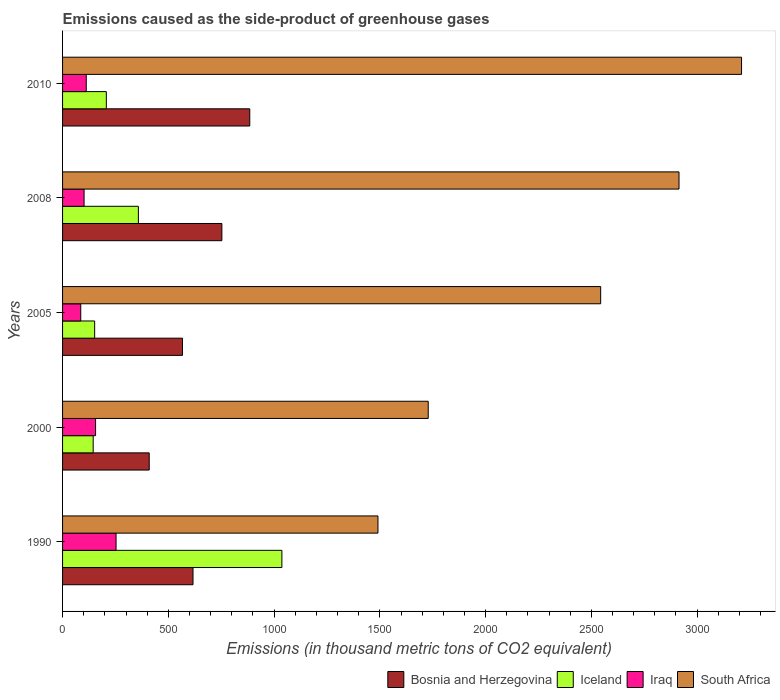Are the number of bars per tick equal to the number of legend labels?
Offer a very short reply. Yes. Are the number of bars on each tick of the Y-axis equal?
Offer a very short reply. Yes. What is the label of the 3rd group of bars from the top?
Your answer should be very brief. 2005. What is the emissions caused as the side-product of greenhouse gases in Bosnia and Herzegovina in 2010?
Provide a short and direct response. 885. Across all years, what is the maximum emissions caused as the side-product of greenhouse gases in Iceland?
Your answer should be very brief. 1036.9. Across all years, what is the minimum emissions caused as the side-product of greenhouse gases in South Africa?
Provide a short and direct response. 1491.1. In which year was the emissions caused as the side-product of greenhouse gases in South Africa maximum?
Ensure brevity in your answer.  2010. In which year was the emissions caused as the side-product of greenhouse gases in South Africa minimum?
Ensure brevity in your answer.  1990. What is the total emissions caused as the side-product of greenhouse gases in Iceland in the graph?
Ensure brevity in your answer.  1898.9. What is the difference between the emissions caused as the side-product of greenhouse gases in Bosnia and Herzegovina in 1990 and that in 2008?
Your answer should be very brief. -136.5. What is the difference between the emissions caused as the side-product of greenhouse gases in Iceland in 2000 and the emissions caused as the side-product of greenhouse gases in Bosnia and Herzegovina in 2008?
Your answer should be very brief. -608.4. What is the average emissions caused as the side-product of greenhouse gases in Iceland per year?
Your response must be concise. 379.78. In the year 2000, what is the difference between the emissions caused as the side-product of greenhouse gases in Iraq and emissions caused as the side-product of greenhouse gases in South Africa?
Offer a very short reply. -1572.7. What is the ratio of the emissions caused as the side-product of greenhouse gases in South Africa in 2008 to that in 2010?
Provide a short and direct response. 0.91. Is the emissions caused as the side-product of greenhouse gases in Iceland in 1990 less than that in 2010?
Give a very brief answer. No. Is the difference between the emissions caused as the side-product of greenhouse gases in Iraq in 2000 and 2010 greater than the difference between the emissions caused as the side-product of greenhouse gases in South Africa in 2000 and 2010?
Give a very brief answer. Yes. What is the difference between the highest and the second highest emissions caused as the side-product of greenhouse gases in Bosnia and Herzegovina?
Your response must be concise. 131.8. What is the difference between the highest and the lowest emissions caused as the side-product of greenhouse gases in South Africa?
Ensure brevity in your answer.  1718.9. In how many years, is the emissions caused as the side-product of greenhouse gases in Iraq greater than the average emissions caused as the side-product of greenhouse gases in Iraq taken over all years?
Provide a succinct answer. 2. Is it the case that in every year, the sum of the emissions caused as the side-product of greenhouse gases in Bosnia and Herzegovina and emissions caused as the side-product of greenhouse gases in Iceland is greater than the sum of emissions caused as the side-product of greenhouse gases in South Africa and emissions caused as the side-product of greenhouse gases in Iraq?
Offer a terse response. No. What does the 1st bar from the top in 2000 represents?
Offer a terse response. South Africa. Is it the case that in every year, the sum of the emissions caused as the side-product of greenhouse gases in Bosnia and Herzegovina and emissions caused as the side-product of greenhouse gases in Iceland is greater than the emissions caused as the side-product of greenhouse gases in Iraq?
Keep it short and to the point. Yes. How many bars are there?
Make the answer very short. 20. Are all the bars in the graph horizontal?
Make the answer very short. Yes. Are the values on the major ticks of X-axis written in scientific E-notation?
Offer a terse response. No. How many legend labels are there?
Provide a short and direct response. 4. What is the title of the graph?
Offer a very short reply. Emissions caused as the side-product of greenhouse gases. What is the label or title of the X-axis?
Give a very brief answer. Emissions (in thousand metric tons of CO2 equivalent). What is the Emissions (in thousand metric tons of CO2 equivalent) in Bosnia and Herzegovina in 1990?
Provide a short and direct response. 616.7. What is the Emissions (in thousand metric tons of CO2 equivalent) in Iceland in 1990?
Ensure brevity in your answer.  1036.9. What is the Emissions (in thousand metric tons of CO2 equivalent) of Iraq in 1990?
Provide a succinct answer. 252.9. What is the Emissions (in thousand metric tons of CO2 equivalent) of South Africa in 1990?
Your answer should be very brief. 1491.1. What is the Emissions (in thousand metric tons of CO2 equivalent) in Bosnia and Herzegovina in 2000?
Provide a succinct answer. 409.7. What is the Emissions (in thousand metric tons of CO2 equivalent) of Iceland in 2000?
Offer a very short reply. 144.8. What is the Emissions (in thousand metric tons of CO2 equivalent) in Iraq in 2000?
Offer a terse response. 156.1. What is the Emissions (in thousand metric tons of CO2 equivalent) of South Africa in 2000?
Offer a terse response. 1728.8. What is the Emissions (in thousand metric tons of CO2 equivalent) of Bosnia and Herzegovina in 2005?
Keep it short and to the point. 566.9. What is the Emissions (in thousand metric tons of CO2 equivalent) of Iceland in 2005?
Ensure brevity in your answer.  151.7. What is the Emissions (in thousand metric tons of CO2 equivalent) in South Africa in 2005?
Provide a succinct answer. 2544. What is the Emissions (in thousand metric tons of CO2 equivalent) of Bosnia and Herzegovina in 2008?
Provide a succinct answer. 753.2. What is the Emissions (in thousand metric tons of CO2 equivalent) in Iceland in 2008?
Your answer should be very brief. 358.5. What is the Emissions (in thousand metric tons of CO2 equivalent) of Iraq in 2008?
Keep it short and to the point. 101.7. What is the Emissions (in thousand metric tons of CO2 equivalent) in South Africa in 2008?
Your response must be concise. 2914.4. What is the Emissions (in thousand metric tons of CO2 equivalent) in Bosnia and Herzegovina in 2010?
Give a very brief answer. 885. What is the Emissions (in thousand metric tons of CO2 equivalent) in Iceland in 2010?
Your answer should be very brief. 207. What is the Emissions (in thousand metric tons of CO2 equivalent) in Iraq in 2010?
Give a very brief answer. 112. What is the Emissions (in thousand metric tons of CO2 equivalent) in South Africa in 2010?
Provide a succinct answer. 3210. Across all years, what is the maximum Emissions (in thousand metric tons of CO2 equivalent) of Bosnia and Herzegovina?
Your answer should be very brief. 885. Across all years, what is the maximum Emissions (in thousand metric tons of CO2 equivalent) of Iceland?
Offer a very short reply. 1036.9. Across all years, what is the maximum Emissions (in thousand metric tons of CO2 equivalent) of Iraq?
Keep it short and to the point. 252.9. Across all years, what is the maximum Emissions (in thousand metric tons of CO2 equivalent) of South Africa?
Provide a short and direct response. 3210. Across all years, what is the minimum Emissions (in thousand metric tons of CO2 equivalent) of Bosnia and Herzegovina?
Keep it short and to the point. 409.7. Across all years, what is the minimum Emissions (in thousand metric tons of CO2 equivalent) in Iceland?
Make the answer very short. 144.8. Across all years, what is the minimum Emissions (in thousand metric tons of CO2 equivalent) in South Africa?
Offer a terse response. 1491.1. What is the total Emissions (in thousand metric tons of CO2 equivalent) of Bosnia and Herzegovina in the graph?
Provide a short and direct response. 3231.5. What is the total Emissions (in thousand metric tons of CO2 equivalent) of Iceland in the graph?
Offer a very short reply. 1898.9. What is the total Emissions (in thousand metric tons of CO2 equivalent) of Iraq in the graph?
Provide a succinct answer. 708.7. What is the total Emissions (in thousand metric tons of CO2 equivalent) in South Africa in the graph?
Offer a very short reply. 1.19e+04. What is the difference between the Emissions (in thousand metric tons of CO2 equivalent) of Bosnia and Herzegovina in 1990 and that in 2000?
Your response must be concise. 207. What is the difference between the Emissions (in thousand metric tons of CO2 equivalent) of Iceland in 1990 and that in 2000?
Keep it short and to the point. 892.1. What is the difference between the Emissions (in thousand metric tons of CO2 equivalent) in Iraq in 1990 and that in 2000?
Provide a succinct answer. 96.8. What is the difference between the Emissions (in thousand metric tons of CO2 equivalent) in South Africa in 1990 and that in 2000?
Offer a very short reply. -237.7. What is the difference between the Emissions (in thousand metric tons of CO2 equivalent) in Bosnia and Herzegovina in 1990 and that in 2005?
Make the answer very short. 49.8. What is the difference between the Emissions (in thousand metric tons of CO2 equivalent) of Iceland in 1990 and that in 2005?
Provide a succinct answer. 885.2. What is the difference between the Emissions (in thousand metric tons of CO2 equivalent) of Iraq in 1990 and that in 2005?
Your response must be concise. 166.9. What is the difference between the Emissions (in thousand metric tons of CO2 equivalent) in South Africa in 1990 and that in 2005?
Your answer should be compact. -1052.9. What is the difference between the Emissions (in thousand metric tons of CO2 equivalent) of Bosnia and Herzegovina in 1990 and that in 2008?
Make the answer very short. -136.5. What is the difference between the Emissions (in thousand metric tons of CO2 equivalent) in Iceland in 1990 and that in 2008?
Ensure brevity in your answer.  678.4. What is the difference between the Emissions (in thousand metric tons of CO2 equivalent) in Iraq in 1990 and that in 2008?
Keep it short and to the point. 151.2. What is the difference between the Emissions (in thousand metric tons of CO2 equivalent) in South Africa in 1990 and that in 2008?
Give a very brief answer. -1423.3. What is the difference between the Emissions (in thousand metric tons of CO2 equivalent) in Bosnia and Herzegovina in 1990 and that in 2010?
Ensure brevity in your answer.  -268.3. What is the difference between the Emissions (in thousand metric tons of CO2 equivalent) of Iceland in 1990 and that in 2010?
Your response must be concise. 829.9. What is the difference between the Emissions (in thousand metric tons of CO2 equivalent) in Iraq in 1990 and that in 2010?
Your answer should be very brief. 140.9. What is the difference between the Emissions (in thousand metric tons of CO2 equivalent) of South Africa in 1990 and that in 2010?
Offer a terse response. -1718.9. What is the difference between the Emissions (in thousand metric tons of CO2 equivalent) in Bosnia and Herzegovina in 2000 and that in 2005?
Your answer should be compact. -157.2. What is the difference between the Emissions (in thousand metric tons of CO2 equivalent) in Iceland in 2000 and that in 2005?
Your response must be concise. -6.9. What is the difference between the Emissions (in thousand metric tons of CO2 equivalent) of Iraq in 2000 and that in 2005?
Your answer should be compact. 70.1. What is the difference between the Emissions (in thousand metric tons of CO2 equivalent) of South Africa in 2000 and that in 2005?
Give a very brief answer. -815.2. What is the difference between the Emissions (in thousand metric tons of CO2 equivalent) in Bosnia and Herzegovina in 2000 and that in 2008?
Ensure brevity in your answer.  -343.5. What is the difference between the Emissions (in thousand metric tons of CO2 equivalent) of Iceland in 2000 and that in 2008?
Make the answer very short. -213.7. What is the difference between the Emissions (in thousand metric tons of CO2 equivalent) in Iraq in 2000 and that in 2008?
Your response must be concise. 54.4. What is the difference between the Emissions (in thousand metric tons of CO2 equivalent) of South Africa in 2000 and that in 2008?
Your answer should be very brief. -1185.6. What is the difference between the Emissions (in thousand metric tons of CO2 equivalent) of Bosnia and Herzegovina in 2000 and that in 2010?
Keep it short and to the point. -475.3. What is the difference between the Emissions (in thousand metric tons of CO2 equivalent) in Iceland in 2000 and that in 2010?
Make the answer very short. -62.2. What is the difference between the Emissions (in thousand metric tons of CO2 equivalent) in Iraq in 2000 and that in 2010?
Your answer should be compact. 44.1. What is the difference between the Emissions (in thousand metric tons of CO2 equivalent) of South Africa in 2000 and that in 2010?
Offer a very short reply. -1481.2. What is the difference between the Emissions (in thousand metric tons of CO2 equivalent) of Bosnia and Herzegovina in 2005 and that in 2008?
Offer a very short reply. -186.3. What is the difference between the Emissions (in thousand metric tons of CO2 equivalent) in Iceland in 2005 and that in 2008?
Provide a short and direct response. -206.8. What is the difference between the Emissions (in thousand metric tons of CO2 equivalent) in Iraq in 2005 and that in 2008?
Make the answer very short. -15.7. What is the difference between the Emissions (in thousand metric tons of CO2 equivalent) in South Africa in 2005 and that in 2008?
Your answer should be compact. -370.4. What is the difference between the Emissions (in thousand metric tons of CO2 equivalent) of Bosnia and Herzegovina in 2005 and that in 2010?
Ensure brevity in your answer.  -318.1. What is the difference between the Emissions (in thousand metric tons of CO2 equivalent) of Iceland in 2005 and that in 2010?
Your answer should be very brief. -55.3. What is the difference between the Emissions (in thousand metric tons of CO2 equivalent) of South Africa in 2005 and that in 2010?
Provide a succinct answer. -666. What is the difference between the Emissions (in thousand metric tons of CO2 equivalent) of Bosnia and Herzegovina in 2008 and that in 2010?
Give a very brief answer. -131.8. What is the difference between the Emissions (in thousand metric tons of CO2 equivalent) in Iceland in 2008 and that in 2010?
Ensure brevity in your answer.  151.5. What is the difference between the Emissions (in thousand metric tons of CO2 equivalent) of Iraq in 2008 and that in 2010?
Offer a terse response. -10.3. What is the difference between the Emissions (in thousand metric tons of CO2 equivalent) of South Africa in 2008 and that in 2010?
Offer a very short reply. -295.6. What is the difference between the Emissions (in thousand metric tons of CO2 equivalent) of Bosnia and Herzegovina in 1990 and the Emissions (in thousand metric tons of CO2 equivalent) of Iceland in 2000?
Provide a succinct answer. 471.9. What is the difference between the Emissions (in thousand metric tons of CO2 equivalent) of Bosnia and Herzegovina in 1990 and the Emissions (in thousand metric tons of CO2 equivalent) of Iraq in 2000?
Ensure brevity in your answer.  460.6. What is the difference between the Emissions (in thousand metric tons of CO2 equivalent) in Bosnia and Herzegovina in 1990 and the Emissions (in thousand metric tons of CO2 equivalent) in South Africa in 2000?
Your answer should be compact. -1112.1. What is the difference between the Emissions (in thousand metric tons of CO2 equivalent) in Iceland in 1990 and the Emissions (in thousand metric tons of CO2 equivalent) in Iraq in 2000?
Make the answer very short. 880.8. What is the difference between the Emissions (in thousand metric tons of CO2 equivalent) of Iceland in 1990 and the Emissions (in thousand metric tons of CO2 equivalent) of South Africa in 2000?
Your answer should be very brief. -691.9. What is the difference between the Emissions (in thousand metric tons of CO2 equivalent) of Iraq in 1990 and the Emissions (in thousand metric tons of CO2 equivalent) of South Africa in 2000?
Offer a terse response. -1475.9. What is the difference between the Emissions (in thousand metric tons of CO2 equivalent) of Bosnia and Herzegovina in 1990 and the Emissions (in thousand metric tons of CO2 equivalent) of Iceland in 2005?
Your answer should be very brief. 465. What is the difference between the Emissions (in thousand metric tons of CO2 equivalent) of Bosnia and Herzegovina in 1990 and the Emissions (in thousand metric tons of CO2 equivalent) of Iraq in 2005?
Offer a terse response. 530.7. What is the difference between the Emissions (in thousand metric tons of CO2 equivalent) in Bosnia and Herzegovina in 1990 and the Emissions (in thousand metric tons of CO2 equivalent) in South Africa in 2005?
Ensure brevity in your answer.  -1927.3. What is the difference between the Emissions (in thousand metric tons of CO2 equivalent) in Iceland in 1990 and the Emissions (in thousand metric tons of CO2 equivalent) in Iraq in 2005?
Provide a succinct answer. 950.9. What is the difference between the Emissions (in thousand metric tons of CO2 equivalent) in Iceland in 1990 and the Emissions (in thousand metric tons of CO2 equivalent) in South Africa in 2005?
Offer a very short reply. -1507.1. What is the difference between the Emissions (in thousand metric tons of CO2 equivalent) of Iraq in 1990 and the Emissions (in thousand metric tons of CO2 equivalent) of South Africa in 2005?
Keep it short and to the point. -2291.1. What is the difference between the Emissions (in thousand metric tons of CO2 equivalent) of Bosnia and Herzegovina in 1990 and the Emissions (in thousand metric tons of CO2 equivalent) of Iceland in 2008?
Your answer should be very brief. 258.2. What is the difference between the Emissions (in thousand metric tons of CO2 equivalent) of Bosnia and Herzegovina in 1990 and the Emissions (in thousand metric tons of CO2 equivalent) of Iraq in 2008?
Give a very brief answer. 515. What is the difference between the Emissions (in thousand metric tons of CO2 equivalent) in Bosnia and Herzegovina in 1990 and the Emissions (in thousand metric tons of CO2 equivalent) in South Africa in 2008?
Ensure brevity in your answer.  -2297.7. What is the difference between the Emissions (in thousand metric tons of CO2 equivalent) of Iceland in 1990 and the Emissions (in thousand metric tons of CO2 equivalent) of Iraq in 2008?
Ensure brevity in your answer.  935.2. What is the difference between the Emissions (in thousand metric tons of CO2 equivalent) in Iceland in 1990 and the Emissions (in thousand metric tons of CO2 equivalent) in South Africa in 2008?
Your answer should be compact. -1877.5. What is the difference between the Emissions (in thousand metric tons of CO2 equivalent) in Iraq in 1990 and the Emissions (in thousand metric tons of CO2 equivalent) in South Africa in 2008?
Your answer should be very brief. -2661.5. What is the difference between the Emissions (in thousand metric tons of CO2 equivalent) of Bosnia and Herzegovina in 1990 and the Emissions (in thousand metric tons of CO2 equivalent) of Iceland in 2010?
Give a very brief answer. 409.7. What is the difference between the Emissions (in thousand metric tons of CO2 equivalent) in Bosnia and Herzegovina in 1990 and the Emissions (in thousand metric tons of CO2 equivalent) in Iraq in 2010?
Offer a very short reply. 504.7. What is the difference between the Emissions (in thousand metric tons of CO2 equivalent) in Bosnia and Herzegovina in 1990 and the Emissions (in thousand metric tons of CO2 equivalent) in South Africa in 2010?
Offer a very short reply. -2593.3. What is the difference between the Emissions (in thousand metric tons of CO2 equivalent) in Iceland in 1990 and the Emissions (in thousand metric tons of CO2 equivalent) in Iraq in 2010?
Your answer should be very brief. 924.9. What is the difference between the Emissions (in thousand metric tons of CO2 equivalent) of Iceland in 1990 and the Emissions (in thousand metric tons of CO2 equivalent) of South Africa in 2010?
Your answer should be very brief. -2173.1. What is the difference between the Emissions (in thousand metric tons of CO2 equivalent) in Iraq in 1990 and the Emissions (in thousand metric tons of CO2 equivalent) in South Africa in 2010?
Provide a succinct answer. -2957.1. What is the difference between the Emissions (in thousand metric tons of CO2 equivalent) of Bosnia and Herzegovina in 2000 and the Emissions (in thousand metric tons of CO2 equivalent) of Iceland in 2005?
Your answer should be compact. 258. What is the difference between the Emissions (in thousand metric tons of CO2 equivalent) in Bosnia and Herzegovina in 2000 and the Emissions (in thousand metric tons of CO2 equivalent) in Iraq in 2005?
Keep it short and to the point. 323.7. What is the difference between the Emissions (in thousand metric tons of CO2 equivalent) of Bosnia and Herzegovina in 2000 and the Emissions (in thousand metric tons of CO2 equivalent) of South Africa in 2005?
Make the answer very short. -2134.3. What is the difference between the Emissions (in thousand metric tons of CO2 equivalent) in Iceland in 2000 and the Emissions (in thousand metric tons of CO2 equivalent) in Iraq in 2005?
Provide a succinct answer. 58.8. What is the difference between the Emissions (in thousand metric tons of CO2 equivalent) in Iceland in 2000 and the Emissions (in thousand metric tons of CO2 equivalent) in South Africa in 2005?
Your answer should be very brief. -2399.2. What is the difference between the Emissions (in thousand metric tons of CO2 equivalent) in Iraq in 2000 and the Emissions (in thousand metric tons of CO2 equivalent) in South Africa in 2005?
Give a very brief answer. -2387.9. What is the difference between the Emissions (in thousand metric tons of CO2 equivalent) of Bosnia and Herzegovina in 2000 and the Emissions (in thousand metric tons of CO2 equivalent) of Iceland in 2008?
Provide a short and direct response. 51.2. What is the difference between the Emissions (in thousand metric tons of CO2 equivalent) in Bosnia and Herzegovina in 2000 and the Emissions (in thousand metric tons of CO2 equivalent) in Iraq in 2008?
Offer a terse response. 308. What is the difference between the Emissions (in thousand metric tons of CO2 equivalent) in Bosnia and Herzegovina in 2000 and the Emissions (in thousand metric tons of CO2 equivalent) in South Africa in 2008?
Offer a terse response. -2504.7. What is the difference between the Emissions (in thousand metric tons of CO2 equivalent) of Iceland in 2000 and the Emissions (in thousand metric tons of CO2 equivalent) of Iraq in 2008?
Offer a terse response. 43.1. What is the difference between the Emissions (in thousand metric tons of CO2 equivalent) of Iceland in 2000 and the Emissions (in thousand metric tons of CO2 equivalent) of South Africa in 2008?
Your answer should be very brief. -2769.6. What is the difference between the Emissions (in thousand metric tons of CO2 equivalent) in Iraq in 2000 and the Emissions (in thousand metric tons of CO2 equivalent) in South Africa in 2008?
Offer a terse response. -2758.3. What is the difference between the Emissions (in thousand metric tons of CO2 equivalent) in Bosnia and Herzegovina in 2000 and the Emissions (in thousand metric tons of CO2 equivalent) in Iceland in 2010?
Keep it short and to the point. 202.7. What is the difference between the Emissions (in thousand metric tons of CO2 equivalent) of Bosnia and Herzegovina in 2000 and the Emissions (in thousand metric tons of CO2 equivalent) of Iraq in 2010?
Provide a succinct answer. 297.7. What is the difference between the Emissions (in thousand metric tons of CO2 equivalent) of Bosnia and Herzegovina in 2000 and the Emissions (in thousand metric tons of CO2 equivalent) of South Africa in 2010?
Provide a short and direct response. -2800.3. What is the difference between the Emissions (in thousand metric tons of CO2 equivalent) in Iceland in 2000 and the Emissions (in thousand metric tons of CO2 equivalent) in Iraq in 2010?
Your answer should be very brief. 32.8. What is the difference between the Emissions (in thousand metric tons of CO2 equivalent) of Iceland in 2000 and the Emissions (in thousand metric tons of CO2 equivalent) of South Africa in 2010?
Make the answer very short. -3065.2. What is the difference between the Emissions (in thousand metric tons of CO2 equivalent) in Iraq in 2000 and the Emissions (in thousand metric tons of CO2 equivalent) in South Africa in 2010?
Your answer should be compact. -3053.9. What is the difference between the Emissions (in thousand metric tons of CO2 equivalent) of Bosnia and Herzegovina in 2005 and the Emissions (in thousand metric tons of CO2 equivalent) of Iceland in 2008?
Make the answer very short. 208.4. What is the difference between the Emissions (in thousand metric tons of CO2 equivalent) in Bosnia and Herzegovina in 2005 and the Emissions (in thousand metric tons of CO2 equivalent) in Iraq in 2008?
Your response must be concise. 465.2. What is the difference between the Emissions (in thousand metric tons of CO2 equivalent) in Bosnia and Herzegovina in 2005 and the Emissions (in thousand metric tons of CO2 equivalent) in South Africa in 2008?
Keep it short and to the point. -2347.5. What is the difference between the Emissions (in thousand metric tons of CO2 equivalent) of Iceland in 2005 and the Emissions (in thousand metric tons of CO2 equivalent) of South Africa in 2008?
Keep it short and to the point. -2762.7. What is the difference between the Emissions (in thousand metric tons of CO2 equivalent) of Iraq in 2005 and the Emissions (in thousand metric tons of CO2 equivalent) of South Africa in 2008?
Your answer should be very brief. -2828.4. What is the difference between the Emissions (in thousand metric tons of CO2 equivalent) of Bosnia and Herzegovina in 2005 and the Emissions (in thousand metric tons of CO2 equivalent) of Iceland in 2010?
Keep it short and to the point. 359.9. What is the difference between the Emissions (in thousand metric tons of CO2 equivalent) of Bosnia and Herzegovina in 2005 and the Emissions (in thousand metric tons of CO2 equivalent) of Iraq in 2010?
Your answer should be compact. 454.9. What is the difference between the Emissions (in thousand metric tons of CO2 equivalent) in Bosnia and Herzegovina in 2005 and the Emissions (in thousand metric tons of CO2 equivalent) in South Africa in 2010?
Offer a very short reply. -2643.1. What is the difference between the Emissions (in thousand metric tons of CO2 equivalent) in Iceland in 2005 and the Emissions (in thousand metric tons of CO2 equivalent) in Iraq in 2010?
Your response must be concise. 39.7. What is the difference between the Emissions (in thousand metric tons of CO2 equivalent) of Iceland in 2005 and the Emissions (in thousand metric tons of CO2 equivalent) of South Africa in 2010?
Your answer should be compact. -3058.3. What is the difference between the Emissions (in thousand metric tons of CO2 equivalent) in Iraq in 2005 and the Emissions (in thousand metric tons of CO2 equivalent) in South Africa in 2010?
Offer a very short reply. -3124. What is the difference between the Emissions (in thousand metric tons of CO2 equivalent) of Bosnia and Herzegovina in 2008 and the Emissions (in thousand metric tons of CO2 equivalent) of Iceland in 2010?
Give a very brief answer. 546.2. What is the difference between the Emissions (in thousand metric tons of CO2 equivalent) in Bosnia and Herzegovina in 2008 and the Emissions (in thousand metric tons of CO2 equivalent) in Iraq in 2010?
Make the answer very short. 641.2. What is the difference between the Emissions (in thousand metric tons of CO2 equivalent) in Bosnia and Herzegovina in 2008 and the Emissions (in thousand metric tons of CO2 equivalent) in South Africa in 2010?
Your response must be concise. -2456.8. What is the difference between the Emissions (in thousand metric tons of CO2 equivalent) in Iceland in 2008 and the Emissions (in thousand metric tons of CO2 equivalent) in Iraq in 2010?
Provide a short and direct response. 246.5. What is the difference between the Emissions (in thousand metric tons of CO2 equivalent) of Iceland in 2008 and the Emissions (in thousand metric tons of CO2 equivalent) of South Africa in 2010?
Keep it short and to the point. -2851.5. What is the difference between the Emissions (in thousand metric tons of CO2 equivalent) of Iraq in 2008 and the Emissions (in thousand metric tons of CO2 equivalent) of South Africa in 2010?
Provide a succinct answer. -3108.3. What is the average Emissions (in thousand metric tons of CO2 equivalent) in Bosnia and Herzegovina per year?
Offer a very short reply. 646.3. What is the average Emissions (in thousand metric tons of CO2 equivalent) in Iceland per year?
Make the answer very short. 379.78. What is the average Emissions (in thousand metric tons of CO2 equivalent) in Iraq per year?
Make the answer very short. 141.74. What is the average Emissions (in thousand metric tons of CO2 equivalent) of South Africa per year?
Your answer should be compact. 2377.66. In the year 1990, what is the difference between the Emissions (in thousand metric tons of CO2 equivalent) in Bosnia and Herzegovina and Emissions (in thousand metric tons of CO2 equivalent) in Iceland?
Provide a succinct answer. -420.2. In the year 1990, what is the difference between the Emissions (in thousand metric tons of CO2 equivalent) in Bosnia and Herzegovina and Emissions (in thousand metric tons of CO2 equivalent) in Iraq?
Make the answer very short. 363.8. In the year 1990, what is the difference between the Emissions (in thousand metric tons of CO2 equivalent) of Bosnia and Herzegovina and Emissions (in thousand metric tons of CO2 equivalent) of South Africa?
Offer a very short reply. -874.4. In the year 1990, what is the difference between the Emissions (in thousand metric tons of CO2 equivalent) in Iceland and Emissions (in thousand metric tons of CO2 equivalent) in Iraq?
Give a very brief answer. 784. In the year 1990, what is the difference between the Emissions (in thousand metric tons of CO2 equivalent) in Iceland and Emissions (in thousand metric tons of CO2 equivalent) in South Africa?
Ensure brevity in your answer.  -454.2. In the year 1990, what is the difference between the Emissions (in thousand metric tons of CO2 equivalent) of Iraq and Emissions (in thousand metric tons of CO2 equivalent) of South Africa?
Provide a succinct answer. -1238.2. In the year 2000, what is the difference between the Emissions (in thousand metric tons of CO2 equivalent) of Bosnia and Herzegovina and Emissions (in thousand metric tons of CO2 equivalent) of Iceland?
Your answer should be very brief. 264.9. In the year 2000, what is the difference between the Emissions (in thousand metric tons of CO2 equivalent) of Bosnia and Herzegovina and Emissions (in thousand metric tons of CO2 equivalent) of Iraq?
Ensure brevity in your answer.  253.6. In the year 2000, what is the difference between the Emissions (in thousand metric tons of CO2 equivalent) of Bosnia and Herzegovina and Emissions (in thousand metric tons of CO2 equivalent) of South Africa?
Your answer should be compact. -1319.1. In the year 2000, what is the difference between the Emissions (in thousand metric tons of CO2 equivalent) in Iceland and Emissions (in thousand metric tons of CO2 equivalent) in Iraq?
Provide a succinct answer. -11.3. In the year 2000, what is the difference between the Emissions (in thousand metric tons of CO2 equivalent) of Iceland and Emissions (in thousand metric tons of CO2 equivalent) of South Africa?
Make the answer very short. -1584. In the year 2000, what is the difference between the Emissions (in thousand metric tons of CO2 equivalent) in Iraq and Emissions (in thousand metric tons of CO2 equivalent) in South Africa?
Offer a terse response. -1572.7. In the year 2005, what is the difference between the Emissions (in thousand metric tons of CO2 equivalent) in Bosnia and Herzegovina and Emissions (in thousand metric tons of CO2 equivalent) in Iceland?
Your response must be concise. 415.2. In the year 2005, what is the difference between the Emissions (in thousand metric tons of CO2 equivalent) in Bosnia and Herzegovina and Emissions (in thousand metric tons of CO2 equivalent) in Iraq?
Make the answer very short. 480.9. In the year 2005, what is the difference between the Emissions (in thousand metric tons of CO2 equivalent) in Bosnia and Herzegovina and Emissions (in thousand metric tons of CO2 equivalent) in South Africa?
Make the answer very short. -1977.1. In the year 2005, what is the difference between the Emissions (in thousand metric tons of CO2 equivalent) in Iceland and Emissions (in thousand metric tons of CO2 equivalent) in Iraq?
Provide a succinct answer. 65.7. In the year 2005, what is the difference between the Emissions (in thousand metric tons of CO2 equivalent) in Iceland and Emissions (in thousand metric tons of CO2 equivalent) in South Africa?
Ensure brevity in your answer.  -2392.3. In the year 2005, what is the difference between the Emissions (in thousand metric tons of CO2 equivalent) in Iraq and Emissions (in thousand metric tons of CO2 equivalent) in South Africa?
Your response must be concise. -2458. In the year 2008, what is the difference between the Emissions (in thousand metric tons of CO2 equivalent) of Bosnia and Herzegovina and Emissions (in thousand metric tons of CO2 equivalent) of Iceland?
Offer a very short reply. 394.7. In the year 2008, what is the difference between the Emissions (in thousand metric tons of CO2 equivalent) of Bosnia and Herzegovina and Emissions (in thousand metric tons of CO2 equivalent) of Iraq?
Make the answer very short. 651.5. In the year 2008, what is the difference between the Emissions (in thousand metric tons of CO2 equivalent) in Bosnia and Herzegovina and Emissions (in thousand metric tons of CO2 equivalent) in South Africa?
Give a very brief answer. -2161.2. In the year 2008, what is the difference between the Emissions (in thousand metric tons of CO2 equivalent) of Iceland and Emissions (in thousand metric tons of CO2 equivalent) of Iraq?
Your response must be concise. 256.8. In the year 2008, what is the difference between the Emissions (in thousand metric tons of CO2 equivalent) of Iceland and Emissions (in thousand metric tons of CO2 equivalent) of South Africa?
Give a very brief answer. -2555.9. In the year 2008, what is the difference between the Emissions (in thousand metric tons of CO2 equivalent) of Iraq and Emissions (in thousand metric tons of CO2 equivalent) of South Africa?
Your answer should be very brief. -2812.7. In the year 2010, what is the difference between the Emissions (in thousand metric tons of CO2 equivalent) in Bosnia and Herzegovina and Emissions (in thousand metric tons of CO2 equivalent) in Iceland?
Offer a terse response. 678. In the year 2010, what is the difference between the Emissions (in thousand metric tons of CO2 equivalent) in Bosnia and Herzegovina and Emissions (in thousand metric tons of CO2 equivalent) in Iraq?
Offer a terse response. 773. In the year 2010, what is the difference between the Emissions (in thousand metric tons of CO2 equivalent) in Bosnia and Herzegovina and Emissions (in thousand metric tons of CO2 equivalent) in South Africa?
Ensure brevity in your answer.  -2325. In the year 2010, what is the difference between the Emissions (in thousand metric tons of CO2 equivalent) of Iceland and Emissions (in thousand metric tons of CO2 equivalent) of South Africa?
Ensure brevity in your answer.  -3003. In the year 2010, what is the difference between the Emissions (in thousand metric tons of CO2 equivalent) of Iraq and Emissions (in thousand metric tons of CO2 equivalent) of South Africa?
Give a very brief answer. -3098. What is the ratio of the Emissions (in thousand metric tons of CO2 equivalent) of Bosnia and Herzegovina in 1990 to that in 2000?
Provide a succinct answer. 1.51. What is the ratio of the Emissions (in thousand metric tons of CO2 equivalent) in Iceland in 1990 to that in 2000?
Give a very brief answer. 7.16. What is the ratio of the Emissions (in thousand metric tons of CO2 equivalent) in Iraq in 1990 to that in 2000?
Your answer should be compact. 1.62. What is the ratio of the Emissions (in thousand metric tons of CO2 equivalent) in South Africa in 1990 to that in 2000?
Your response must be concise. 0.86. What is the ratio of the Emissions (in thousand metric tons of CO2 equivalent) in Bosnia and Herzegovina in 1990 to that in 2005?
Offer a terse response. 1.09. What is the ratio of the Emissions (in thousand metric tons of CO2 equivalent) of Iceland in 1990 to that in 2005?
Ensure brevity in your answer.  6.84. What is the ratio of the Emissions (in thousand metric tons of CO2 equivalent) of Iraq in 1990 to that in 2005?
Offer a terse response. 2.94. What is the ratio of the Emissions (in thousand metric tons of CO2 equivalent) of South Africa in 1990 to that in 2005?
Your response must be concise. 0.59. What is the ratio of the Emissions (in thousand metric tons of CO2 equivalent) of Bosnia and Herzegovina in 1990 to that in 2008?
Provide a succinct answer. 0.82. What is the ratio of the Emissions (in thousand metric tons of CO2 equivalent) of Iceland in 1990 to that in 2008?
Ensure brevity in your answer.  2.89. What is the ratio of the Emissions (in thousand metric tons of CO2 equivalent) in Iraq in 1990 to that in 2008?
Provide a short and direct response. 2.49. What is the ratio of the Emissions (in thousand metric tons of CO2 equivalent) in South Africa in 1990 to that in 2008?
Offer a terse response. 0.51. What is the ratio of the Emissions (in thousand metric tons of CO2 equivalent) of Bosnia and Herzegovina in 1990 to that in 2010?
Offer a very short reply. 0.7. What is the ratio of the Emissions (in thousand metric tons of CO2 equivalent) of Iceland in 1990 to that in 2010?
Offer a terse response. 5.01. What is the ratio of the Emissions (in thousand metric tons of CO2 equivalent) of Iraq in 1990 to that in 2010?
Your answer should be compact. 2.26. What is the ratio of the Emissions (in thousand metric tons of CO2 equivalent) of South Africa in 1990 to that in 2010?
Offer a very short reply. 0.46. What is the ratio of the Emissions (in thousand metric tons of CO2 equivalent) in Bosnia and Herzegovina in 2000 to that in 2005?
Offer a terse response. 0.72. What is the ratio of the Emissions (in thousand metric tons of CO2 equivalent) of Iceland in 2000 to that in 2005?
Offer a terse response. 0.95. What is the ratio of the Emissions (in thousand metric tons of CO2 equivalent) of Iraq in 2000 to that in 2005?
Offer a very short reply. 1.82. What is the ratio of the Emissions (in thousand metric tons of CO2 equivalent) in South Africa in 2000 to that in 2005?
Offer a terse response. 0.68. What is the ratio of the Emissions (in thousand metric tons of CO2 equivalent) in Bosnia and Herzegovina in 2000 to that in 2008?
Your answer should be very brief. 0.54. What is the ratio of the Emissions (in thousand metric tons of CO2 equivalent) in Iceland in 2000 to that in 2008?
Keep it short and to the point. 0.4. What is the ratio of the Emissions (in thousand metric tons of CO2 equivalent) of Iraq in 2000 to that in 2008?
Your response must be concise. 1.53. What is the ratio of the Emissions (in thousand metric tons of CO2 equivalent) in South Africa in 2000 to that in 2008?
Keep it short and to the point. 0.59. What is the ratio of the Emissions (in thousand metric tons of CO2 equivalent) in Bosnia and Herzegovina in 2000 to that in 2010?
Give a very brief answer. 0.46. What is the ratio of the Emissions (in thousand metric tons of CO2 equivalent) of Iceland in 2000 to that in 2010?
Offer a terse response. 0.7. What is the ratio of the Emissions (in thousand metric tons of CO2 equivalent) of Iraq in 2000 to that in 2010?
Your response must be concise. 1.39. What is the ratio of the Emissions (in thousand metric tons of CO2 equivalent) of South Africa in 2000 to that in 2010?
Keep it short and to the point. 0.54. What is the ratio of the Emissions (in thousand metric tons of CO2 equivalent) in Bosnia and Herzegovina in 2005 to that in 2008?
Keep it short and to the point. 0.75. What is the ratio of the Emissions (in thousand metric tons of CO2 equivalent) of Iceland in 2005 to that in 2008?
Your response must be concise. 0.42. What is the ratio of the Emissions (in thousand metric tons of CO2 equivalent) in Iraq in 2005 to that in 2008?
Provide a short and direct response. 0.85. What is the ratio of the Emissions (in thousand metric tons of CO2 equivalent) in South Africa in 2005 to that in 2008?
Make the answer very short. 0.87. What is the ratio of the Emissions (in thousand metric tons of CO2 equivalent) of Bosnia and Herzegovina in 2005 to that in 2010?
Your answer should be very brief. 0.64. What is the ratio of the Emissions (in thousand metric tons of CO2 equivalent) of Iceland in 2005 to that in 2010?
Keep it short and to the point. 0.73. What is the ratio of the Emissions (in thousand metric tons of CO2 equivalent) of Iraq in 2005 to that in 2010?
Keep it short and to the point. 0.77. What is the ratio of the Emissions (in thousand metric tons of CO2 equivalent) of South Africa in 2005 to that in 2010?
Your response must be concise. 0.79. What is the ratio of the Emissions (in thousand metric tons of CO2 equivalent) of Bosnia and Herzegovina in 2008 to that in 2010?
Your answer should be very brief. 0.85. What is the ratio of the Emissions (in thousand metric tons of CO2 equivalent) in Iceland in 2008 to that in 2010?
Provide a short and direct response. 1.73. What is the ratio of the Emissions (in thousand metric tons of CO2 equivalent) in Iraq in 2008 to that in 2010?
Keep it short and to the point. 0.91. What is the ratio of the Emissions (in thousand metric tons of CO2 equivalent) in South Africa in 2008 to that in 2010?
Your answer should be compact. 0.91. What is the difference between the highest and the second highest Emissions (in thousand metric tons of CO2 equivalent) in Bosnia and Herzegovina?
Your answer should be compact. 131.8. What is the difference between the highest and the second highest Emissions (in thousand metric tons of CO2 equivalent) of Iceland?
Give a very brief answer. 678.4. What is the difference between the highest and the second highest Emissions (in thousand metric tons of CO2 equivalent) of Iraq?
Provide a succinct answer. 96.8. What is the difference between the highest and the second highest Emissions (in thousand metric tons of CO2 equivalent) of South Africa?
Provide a short and direct response. 295.6. What is the difference between the highest and the lowest Emissions (in thousand metric tons of CO2 equivalent) of Bosnia and Herzegovina?
Your answer should be compact. 475.3. What is the difference between the highest and the lowest Emissions (in thousand metric tons of CO2 equivalent) of Iceland?
Provide a succinct answer. 892.1. What is the difference between the highest and the lowest Emissions (in thousand metric tons of CO2 equivalent) of Iraq?
Offer a very short reply. 166.9. What is the difference between the highest and the lowest Emissions (in thousand metric tons of CO2 equivalent) of South Africa?
Ensure brevity in your answer.  1718.9. 